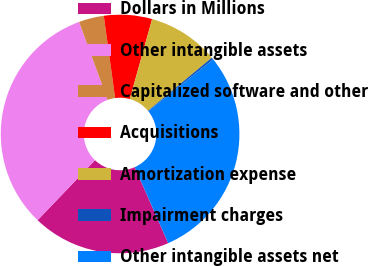<chart> <loc_0><loc_0><loc_500><loc_500><pie_chart><fcel>Dollars in Millions<fcel>Other intangible assets<fcel>Capitalized software and other<fcel>Acquisitions<fcel>Amortization expense<fcel>Impairment charges<fcel>Other intangible assets net<nl><fcel>18.76%<fcel>32.27%<fcel>3.4%<fcel>6.51%<fcel>9.63%<fcel>0.28%<fcel>29.15%<nl></chart> 